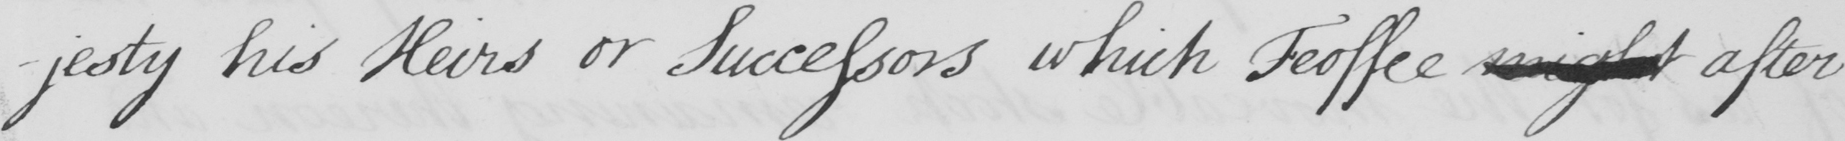Please provide the text content of this handwritten line. -jesty his Heirs or Successors which Feoffee might after 